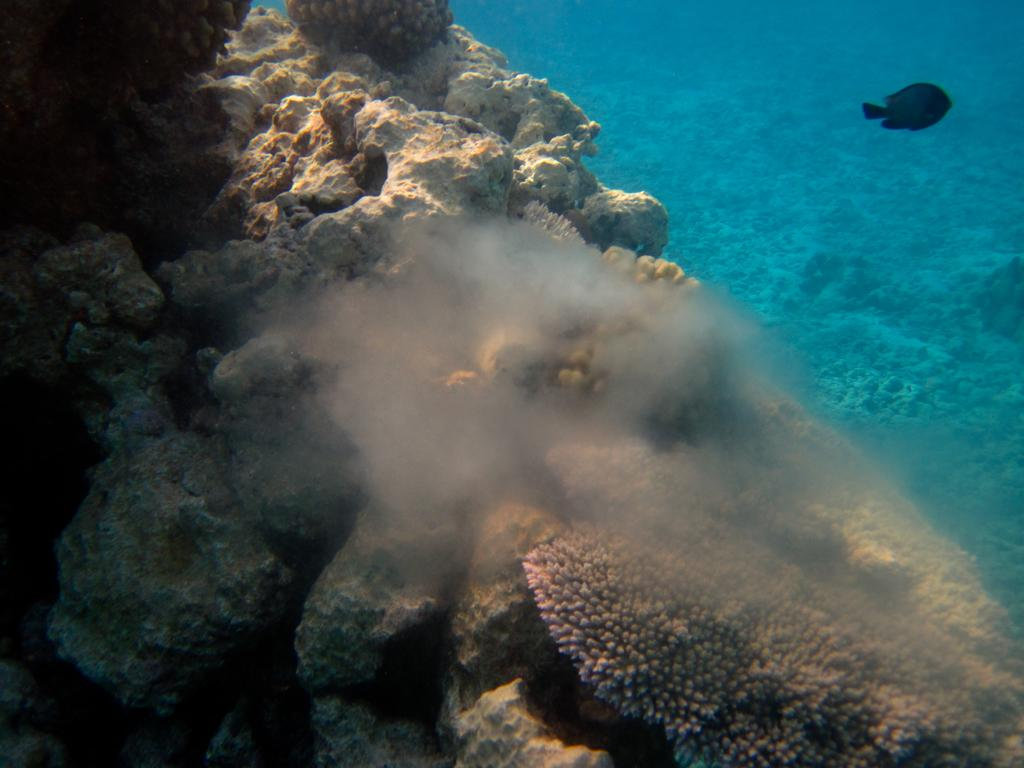What is located in the water in the image? There is a rock in the water in the image. What can be seen near the rock? There is a fish beside the rock. What type of amusement can be seen in the image? There is no amusement present in the image; it features a rock and a fish in the water. What role does the soap play in the image? There is no soap present in the image. 